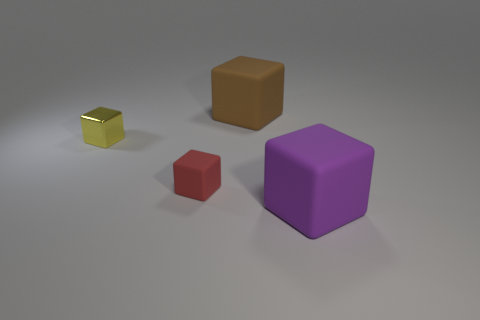Subtract all yellow shiny blocks. How many blocks are left? 3 Subtract all purple blocks. How many blocks are left? 3 Add 4 small red things. How many objects exist? 8 Subtract 2 cubes. How many cubes are left? 2 Add 3 large gray rubber cylinders. How many large gray rubber cylinders exist? 3 Subtract 0 cyan balls. How many objects are left? 4 Subtract all gray blocks. Subtract all purple balls. How many blocks are left? 4 Subtract all purple cylinders. How many purple cubes are left? 1 Subtract all big brown matte things. Subtract all yellow shiny cubes. How many objects are left? 2 Add 1 cubes. How many cubes are left? 5 